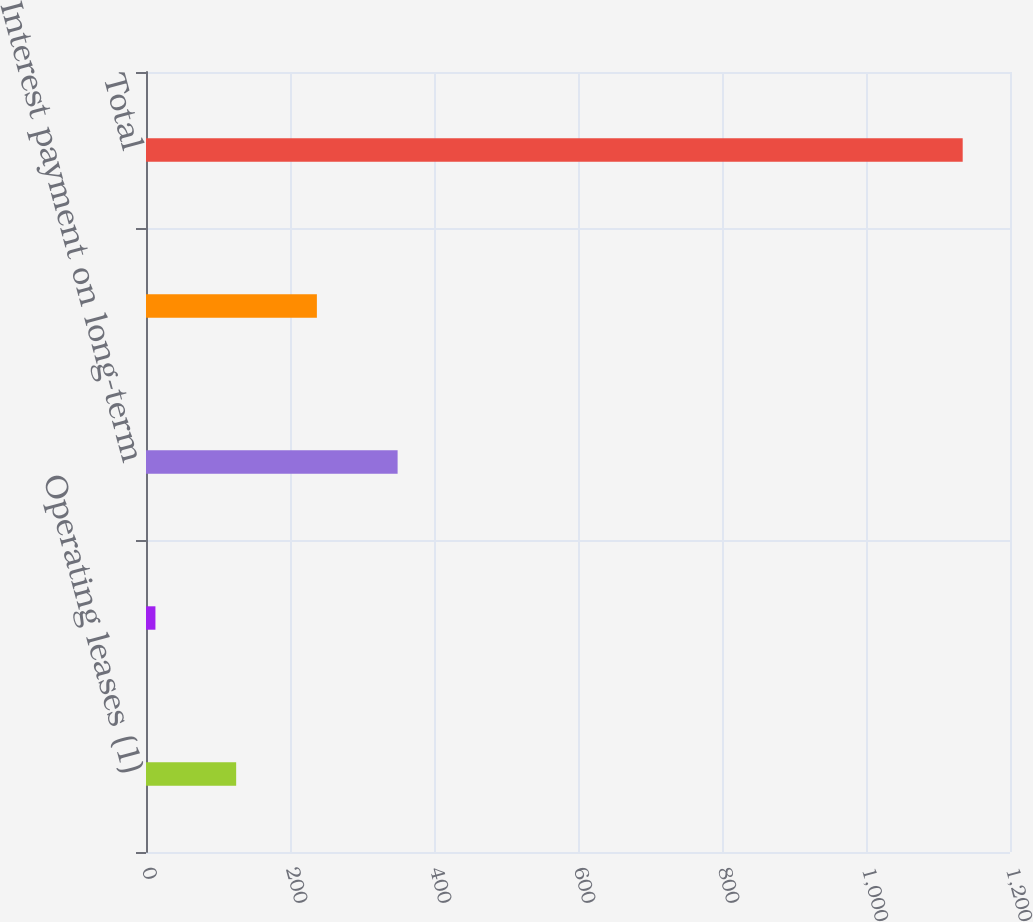<chart> <loc_0><loc_0><loc_500><loc_500><bar_chart><fcel>Operating leases (1)<fcel>Other lease arrangement (2)<fcel>Interest payment on long-term<fcel>Other contractual obligations<fcel>Total<nl><fcel>125.22<fcel>13.1<fcel>349.46<fcel>237.34<fcel>1134.3<nl></chart> 